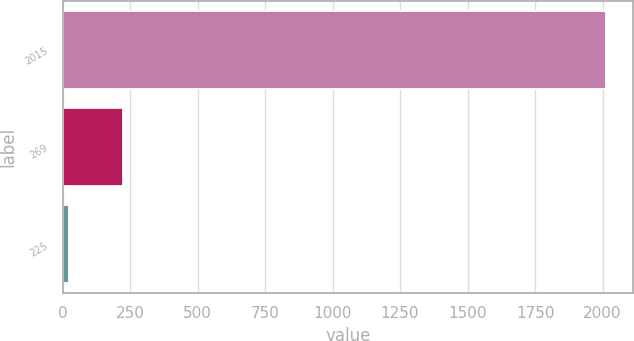Convert chart to OTSL. <chart><loc_0><loc_0><loc_500><loc_500><bar_chart><fcel>2015<fcel>269<fcel>225<nl><fcel>2013<fcel>223.17<fcel>24.3<nl></chart> 